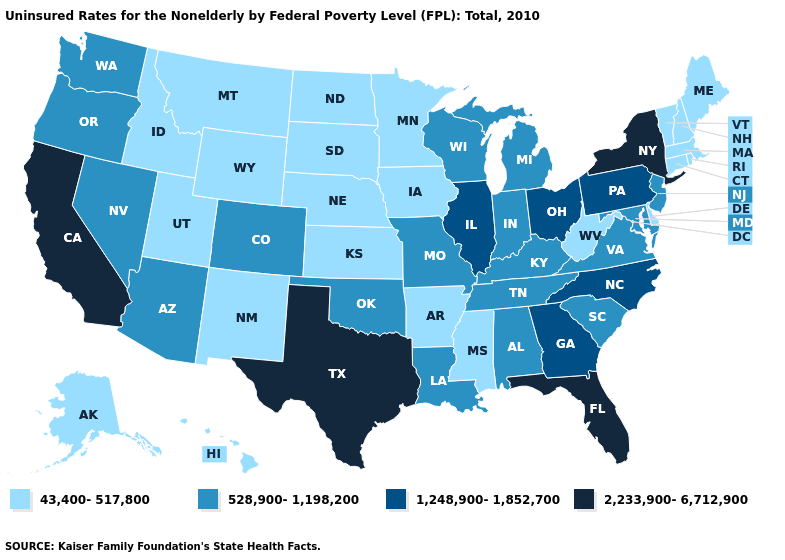Does the map have missing data?
Short answer required. No. Does New Mexico have the highest value in the West?
Answer briefly. No. Does New York have the highest value in the Northeast?
Give a very brief answer. Yes. Which states have the lowest value in the MidWest?
Give a very brief answer. Iowa, Kansas, Minnesota, Nebraska, North Dakota, South Dakota. Does the first symbol in the legend represent the smallest category?
Answer briefly. Yes. Which states hav the highest value in the South?
Concise answer only. Florida, Texas. What is the value of Vermont?
Keep it brief. 43,400-517,800. What is the lowest value in the West?
Give a very brief answer. 43,400-517,800. Name the states that have a value in the range 528,900-1,198,200?
Keep it brief. Alabama, Arizona, Colorado, Indiana, Kentucky, Louisiana, Maryland, Michigan, Missouri, Nevada, New Jersey, Oklahoma, Oregon, South Carolina, Tennessee, Virginia, Washington, Wisconsin. Which states have the lowest value in the MidWest?
Write a very short answer. Iowa, Kansas, Minnesota, Nebraska, North Dakota, South Dakota. Does the map have missing data?
Answer briefly. No. What is the lowest value in the USA?
Keep it brief. 43,400-517,800. Name the states that have a value in the range 43,400-517,800?
Concise answer only. Alaska, Arkansas, Connecticut, Delaware, Hawaii, Idaho, Iowa, Kansas, Maine, Massachusetts, Minnesota, Mississippi, Montana, Nebraska, New Hampshire, New Mexico, North Dakota, Rhode Island, South Dakota, Utah, Vermont, West Virginia, Wyoming. Name the states that have a value in the range 43,400-517,800?
Give a very brief answer. Alaska, Arkansas, Connecticut, Delaware, Hawaii, Idaho, Iowa, Kansas, Maine, Massachusetts, Minnesota, Mississippi, Montana, Nebraska, New Hampshire, New Mexico, North Dakota, Rhode Island, South Dakota, Utah, Vermont, West Virginia, Wyoming. Which states have the lowest value in the USA?
Write a very short answer. Alaska, Arkansas, Connecticut, Delaware, Hawaii, Idaho, Iowa, Kansas, Maine, Massachusetts, Minnesota, Mississippi, Montana, Nebraska, New Hampshire, New Mexico, North Dakota, Rhode Island, South Dakota, Utah, Vermont, West Virginia, Wyoming. 